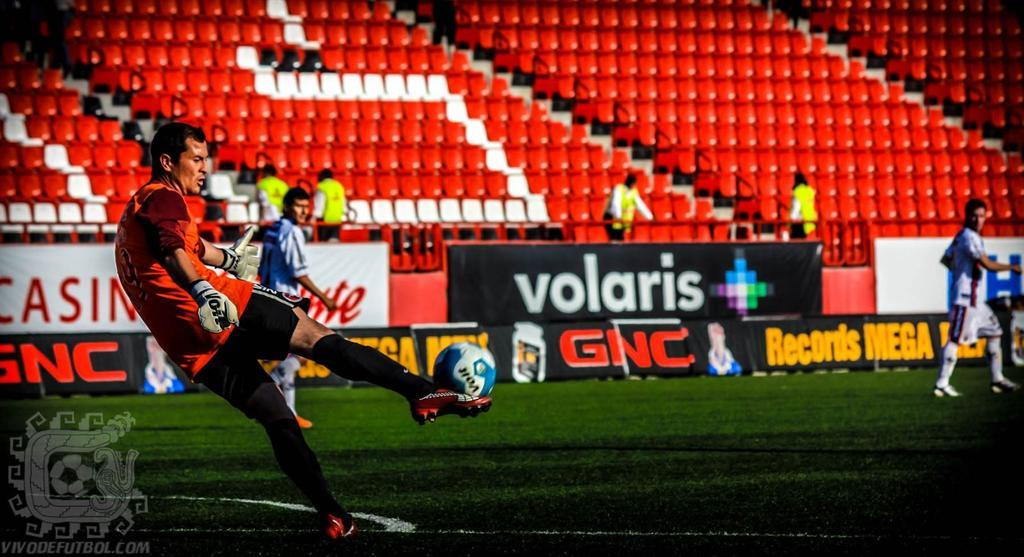<image>
Create a compact narrative representing the image presented. the word Volaris is on a sign outside 